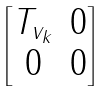Convert formula to latex. <formula><loc_0><loc_0><loc_500><loc_500>\begin{bmatrix} T _ { v _ { k } } & 0 \\ 0 & 0 \end{bmatrix}</formula> 